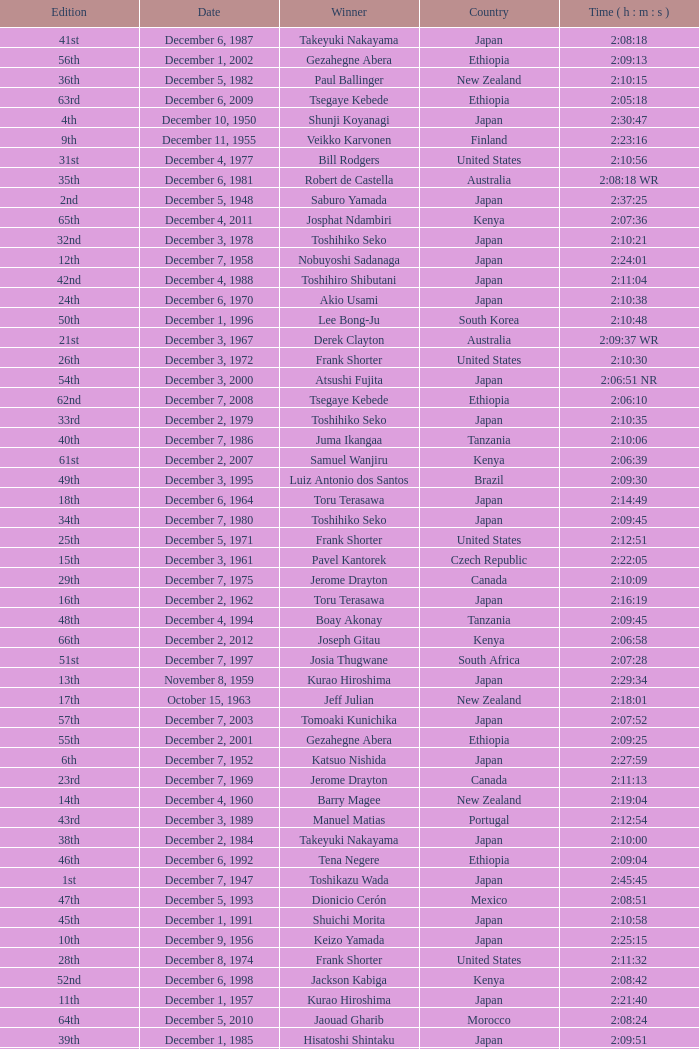Could you help me parse every detail presented in this table? {'header': ['Edition', 'Date', 'Winner', 'Country', 'Time ( h : m : s )'], 'rows': [['41st', 'December 6, 1987', 'Takeyuki Nakayama', 'Japan', '2:08:18'], ['56th', 'December 1, 2002', 'Gezahegne Abera', 'Ethiopia', '2:09:13'], ['36th', 'December 5, 1982', 'Paul Ballinger', 'New Zealand', '2:10:15'], ['63rd', 'December 6, 2009', 'Tsegaye Kebede', 'Ethiopia', '2:05:18'], ['4th', 'December 10, 1950', 'Shunji Koyanagi', 'Japan', '2:30:47'], ['9th', 'December 11, 1955', 'Veikko Karvonen', 'Finland', '2:23:16'], ['31st', 'December 4, 1977', 'Bill Rodgers', 'United States', '2:10:56'], ['35th', 'December 6, 1981', 'Robert de Castella', 'Australia', '2:08:18 WR'], ['2nd', 'December 5, 1948', 'Saburo Yamada', 'Japan', '2:37:25'], ['65th', 'December 4, 2011', 'Josphat Ndambiri', 'Kenya', '2:07:36'], ['32nd', 'December 3, 1978', 'Toshihiko Seko', 'Japan', '2:10:21'], ['12th', 'December 7, 1958', 'Nobuyoshi Sadanaga', 'Japan', '2:24:01'], ['42nd', 'December 4, 1988', 'Toshihiro Shibutani', 'Japan', '2:11:04'], ['24th', 'December 6, 1970', 'Akio Usami', 'Japan', '2:10:38'], ['50th', 'December 1, 1996', 'Lee Bong-Ju', 'South Korea', '2:10:48'], ['21st', 'December 3, 1967', 'Derek Clayton', 'Australia', '2:09:37 WR'], ['26th', 'December 3, 1972', 'Frank Shorter', 'United States', '2:10:30'], ['54th', 'December 3, 2000', 'Atsushi Fujita', 'Japan', '2:06:51 NR'], ['62nd', 'December 7, 2008', 'Tsegaye Kebede', 'Ethiopia', '2:06:10'], ['33rd', 'December 2, 1979', 'Toshihiko Seko', 'Japan', '2:10:35'], ['40th', 'December 7, 1986', 'Juma Ikangaa', 'Tanzania', '2:10:06'], ['61st', 'December 2, 2007', 'Samuel Wanjiru', 'Kenya', '2:06:39'], ['49th', 'December 3, 1995', 'Luiz Antonio dos Santos', 'Brazil', '2:09:30'], ['18th', 'December 6, 1964', 'Toru Terasawa', 'Japan', '2:14:49'], ['34th', 'December 7, 1980', 'Toshihiko Seko', 'Japan', '2:09:45'], ['25th', 'December 5, 1971', 'Frank Shorter', 'United States', '2:12:51'], ['15th', 'December 3, 1961', 'Pavel Kantorek', 'Czech Republic', '2:22:05'], ['29th', 'December 7, 1975', 'Jerome Drayton', 'Canada', '2:10:09'], ['16th', 'December 2, 1962', 'Toru Terasawa', 'Japan', '2:16:19'], ['48th', 'December 4, 1994', 'Boay Akonay', 'Tanzania', '2:09:45'], ['66th', 'December 2, 2012', 'Joseph Gitau', 'Kenya', '2:06:58'], ['51st', 'December 7, 1997', 'Josia Thugwane', 'South Africa', '2:07:28'], ['13th', 'November 8, 1959', 'Kurao Hiroshima', 'Japan', '2:29:34'], ['17th', 'October 15, 1963', 'Jeff Julian', 'New Zealand', '2:18:01'], ['57th', 'December 7, 2003', 'Tomoaki Kunichika', 'Japan', '2:07:52'], ['55th', 'December 2, 2001', 'Gezahegne Abera', 'Ethiopia', '2:09:25'], ['6th', 'December 7, 1952', 'Katsuo Nishida', 'Japan', '2:27:59'], ['23rd', 'December 7, 1969', 'Jerome Drayton', 'Canada', '2:11:13'], ['14th', 'December 4, 1960', 'Barry Magee', 'New Zealand', '2:19:04'], ['43rd', 'December 3, 1989', 'Manuel Matias', 'Portugal', '2:12:54'], ['38th', 'December 2, 1984', 'Takeyuki Nakayama', 'Japan', '2:10:00'], ['46th', 'December 6, 1992', 'Tena Negere', 'Ethiopia', '2:09:04'], ['1st', 'December 7, 1947', 'Toshikazu Wada', 'Japan', '2:45:45'], ['47th', 'December 5, 1993', 'Dionicio Cerón', 'Mexico', '2:08:51'], ['45th', 'December 1, 1991', 'Shuichi Morita', 'Japan', '2:10:58'], ['10th', 'December 9, 1956', 'Keizo Yamada', 'Japan', '2:25:15'], ['28th', 'December 8, 1974', 'Frank Shorter', 'United States', '2:11:32'], ['52nd', 'December 6, 1998', 'Jackson Kabiga', 'Kenya', '2:08:42'], ['11th', 'December 1, 1957', 'Kurao Hiroshima', 'Japan', '2:21:40'], ['64th', 'December 5, 2010', 'Jaouad Gharib', 'Morocco', '2:08:24'], ['39th', 'December 1, 1985', 'Hisatoshi Shintaku', 'Japan', '2:09:51'], ['5th', 'December 9, 1951', 'Hiromi Haigo', 'Japan', '2:30:13'], ['27th', 'December 2, 1973', 'Frank Shorter', 'United States', '2:11:45'], ['7th', 'December 6, 1953', 'Hideo Hamamura', 'Japan', '2:27:26'], ['44th', 'December 2, 1990', 'Belayneh Densamo', 'Ethiopia', '2:11:35'], ['37th', 'December 4, 1983', 'Toshihiko Seko', 'Japan', '2:08:52'], ['53rd', 'December 5, 1999', 'Gezahegne Abera', 'Ethiopia', '2:07:54'], ['8th', 'December 5, 1954', 'Reinaldo Gorno', 'Argentina', '2:24:55'], ['59th', 'December 4, 2005', 'Dmytro Baranovskyy', 'Ukraine', '2:08:29'], ['22nd', 'December 8, 1968', 'Bill Adcocks', 'England', '2:10:48'], ['30th', 'December 5, 1976', 'Jerome Drayton', 'Canada', '2:12:35'], ['58th', 'December 5, 2004', 'Tsuyoshi Ogata', 'Japan', '2:09:10'], ['19th', 'October 10, 1965', 'Hidekuni Hiroshima', 'Japan', '2:18:36'], ['60th', 'December 3, 2006', 'Haile Gebreselassie', 'Ethiopia', '2:06:52'], ['20th', 'November 27, 1966', 'Mike Ryan', 'New Zealand', '2:14:05'], ['3rd', 'December 4, 1949', 'Shinzo Koga', 'Japan', '2:40:26']]} What was the nationality of the winner on December 8, 1968? England. 